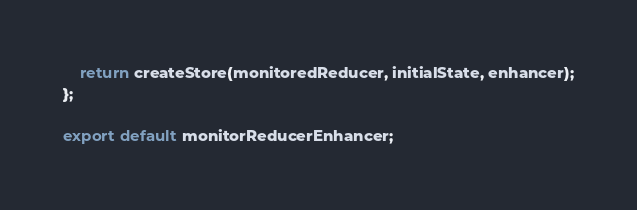<code> <loc_0><loc_0><loc_500><loc_500><_JavaScript_>
	return createStore(monitoredReducer, initialState, enhancer);
};

export default monitorReducerEnhancer;
</code> 